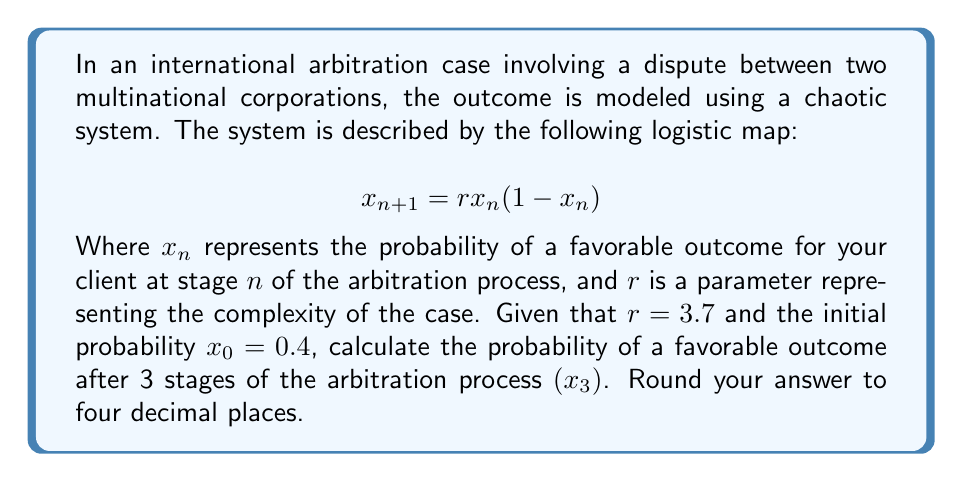Show me your answer to this math problem. To solve this problem, we need to iterate the logistic map equation three times:

Step 1: Calculate $x_1$
$$x_1 = r \cdot x_0 \cdot (1-x_0)$$
$$x_1 = 3.7 \cdot 0.4 \cdot (1-0.4)$$
$$x_1 = 3.7 \cdot 0.4 \cdot 0.6$$
$$x_1 = 0.888$$

Step 2: Calculate $x_2$
$$x_2 = r \cdot x_1 \cdot (1-x_1)$$
$$x_2 = 3.7 \cdot 0.888 \cdot (1-0.888)$$
$$x_2 = 3.7 \cdot 0.888 \cdot 0.112$$
$$x_2 = 0.3682$$

Step 3: Calculate $x_3$
$$x_3 = r \cdot x_2 \cdot (1-x_2)$$
$$x_3 = 3.7 \cdot 0.3682 \cdot (1-0.3682)$$
$$x_3 = 3.7 \cdot 0.3682 \cdot 0.6318$$
$$x_3 = 0.8616$$

Step 4: Round the result to four decimal places
$$x_3 \approx 0.8616$$

This final value represents the probability of a favorable outcome for your client after 3 stages of the arbitration process, according to the chaotic model.
Answer: 0.8616 